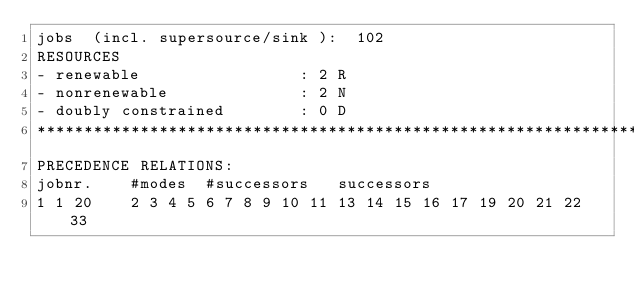<code> <loc_0><loc_0><loc_500><loc_500><_ObjectiveC_>jobs  (incl. supersource/sink ):	102
RESOURCES
- renewable                 : 2 R
- nonrenewable              : 2 N
- doubly constrained        : 0 D
************************************************************************
PRECEDENCE RELATIONS:
jobnr.    #modes  #successors   successors
1	1	20		2 3 4 5 6 7 8 9 10 11 13 14 15 16 17 19 20 21 22 33 </code> 